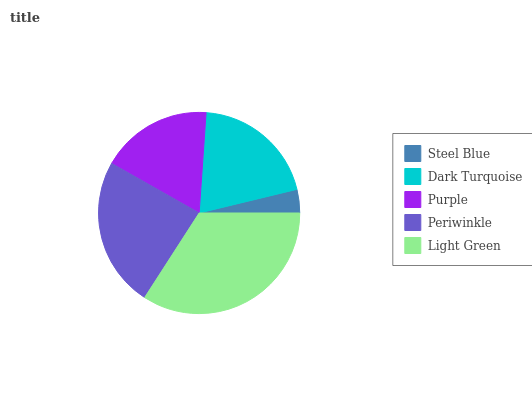Is Steel Blue the minimum?
Answer yes or no. Yes. Is Light Green the maximum?
Answer yes or no. Yes. Is Dark Turquoise the minimum?
Answer yes or no. No. Is Dark Turquoise the maximum?
Answer yes or no. No. Is Dark Turquoise greater than Steel Blue?
Answer yes or no. Yes. Is Steel Blue less than Dark Turquoise?
Answer yes or no. Yes. Is Steel Blue greater than Dark Turquoise?
Answer yes or no. No. Is Dark Turquoise less than Steel Blue?
Answer yes or no. No. Is Dark Turquoise the high median?
Answer yes or no. Yes. Is Dark Turquoise the low median?
Answer yes or no. Yes. Is Purple the high median?
Answer yes or no. No. Is Steel Blue the low median?
Answer yes or no. No. 